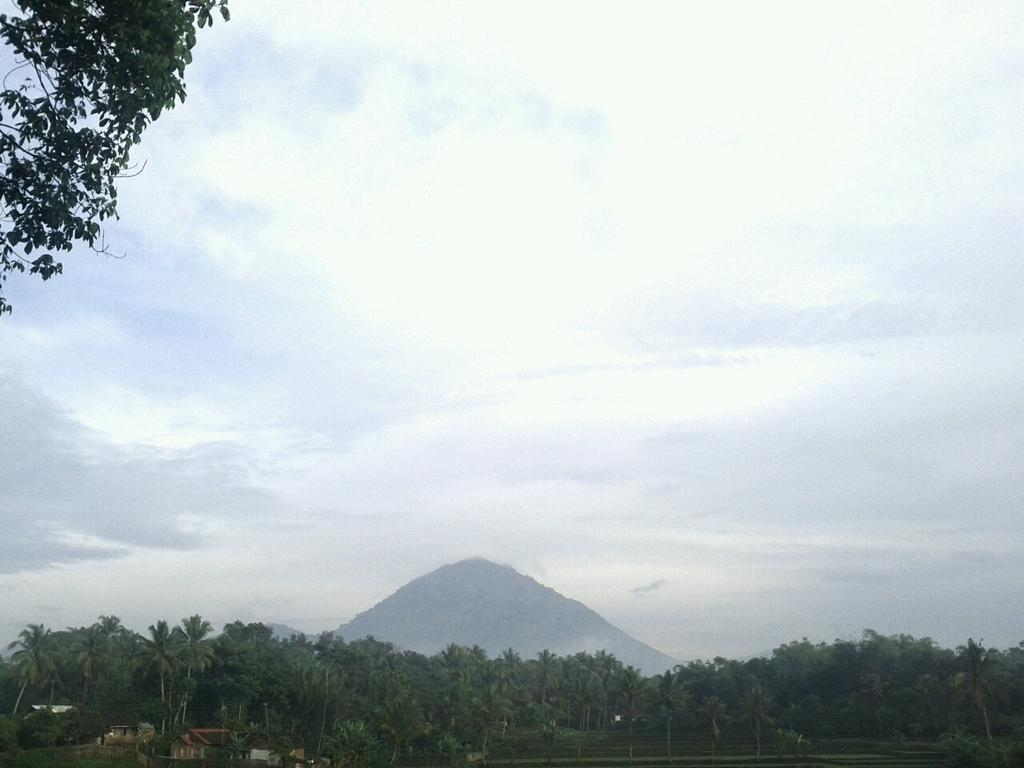What type of vegetation can be seen in the image? There are trees in the image. What is the color of the trees? The trees are green in color. What type of structures are present in the image? There are houses in the image. What geographical feature can be seen in the image? There is a mountain in the image. What is visible in the background of the image? The sky is visible in the background of the image. Can you tell me how many apples are on the mountain in the image? There are no apples present in the image; it features trees, houses, and a mountain. Is there a spy visible in the image? There is no spy present in the image. 